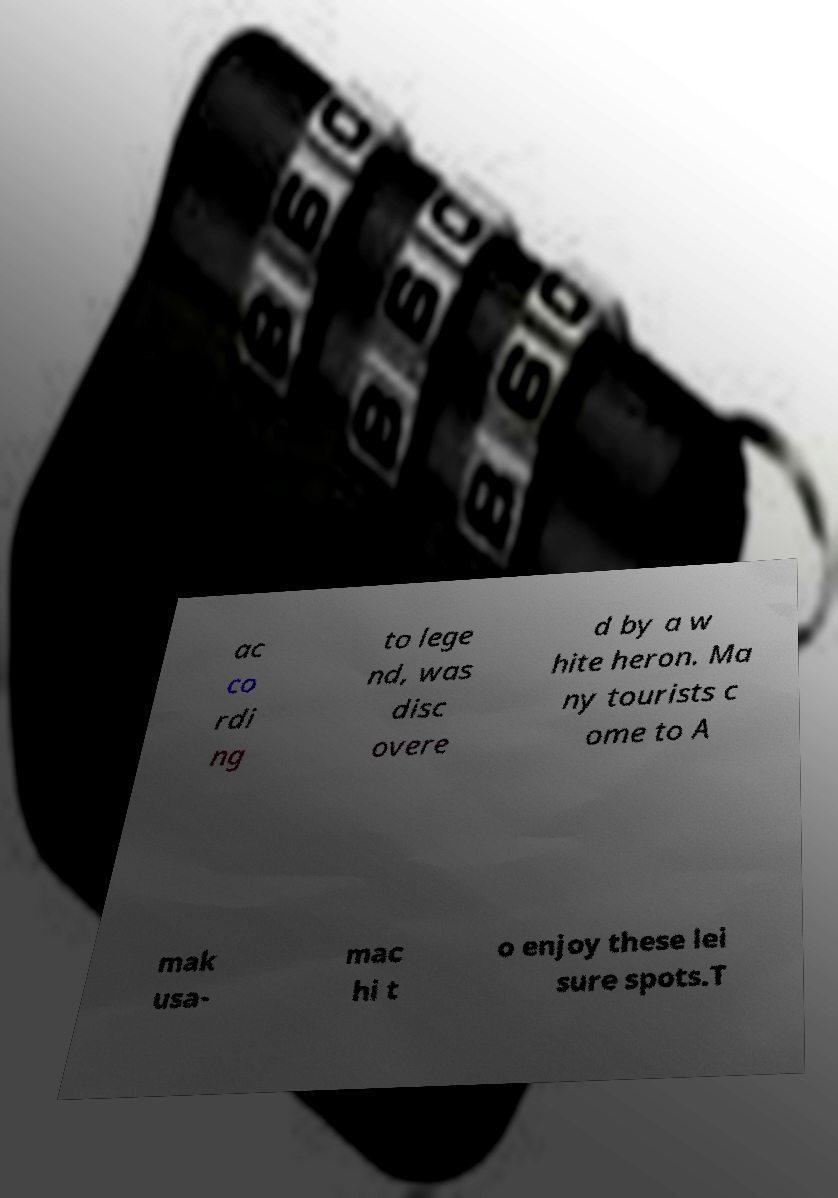For documentation purposes, I need the text within this image transcribed. Could you provide that? ac co rdi ng to lege nd, was disc overe d by a w hite heron. Ma ny tourists c ome to A mak usa- mac hi t o enjoy these lei sure spots.T 